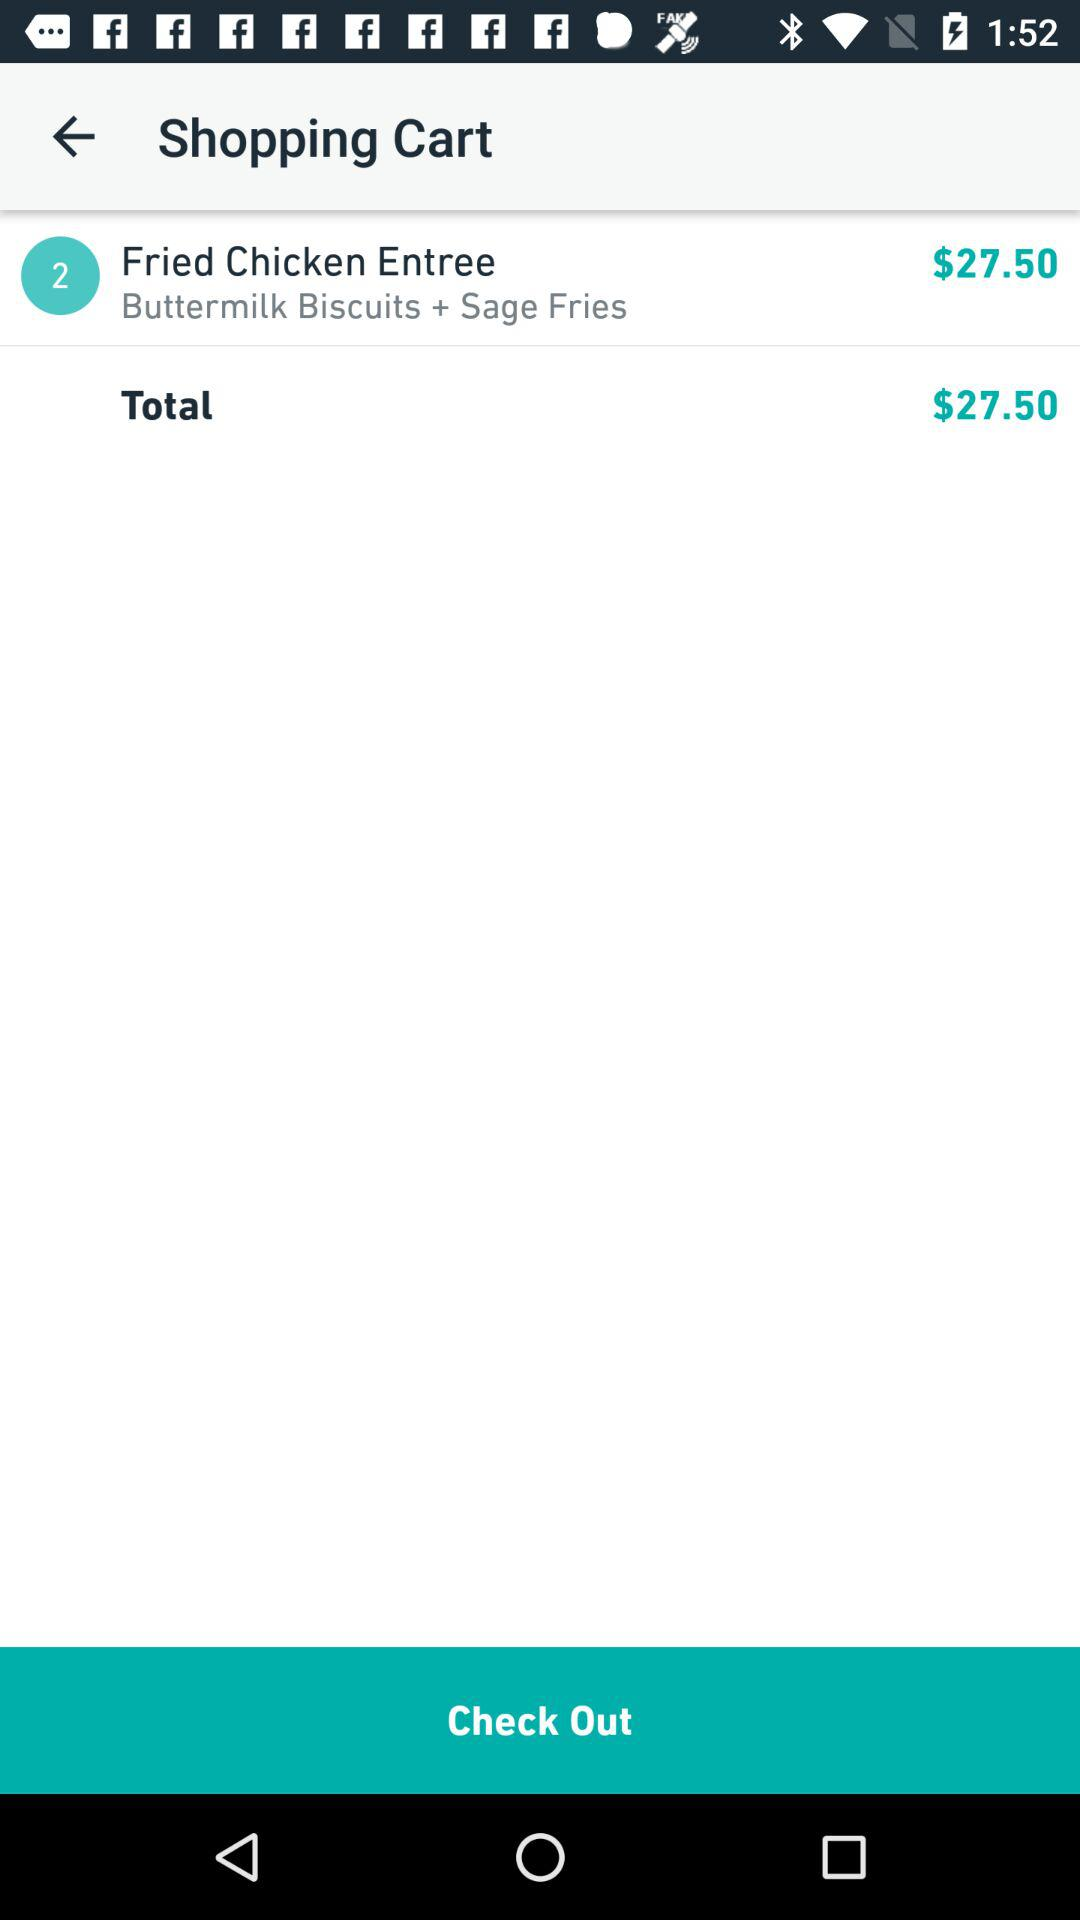What is the price for a fried chicken entree? The price is $27.50. 